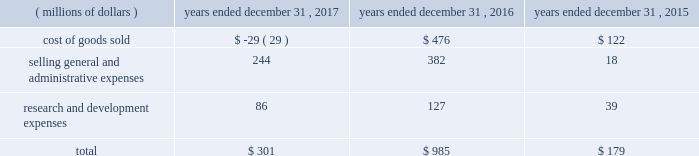Between the actual return on plan assets compared to the expected return on plan assets ( u.s .
Pension plans had an actual rate of return of 7.8 percent compared to an expected rate of return of 6.9 percent ) .
2022 2015 net mark-to-market loss of $ 179 million - primarily due to the difference between the actual return on plan assets compared to the expected return on plan assets ( u.s .
Pension plans had an actual rate of return of ( 2.0 ) percent compared to an expected rate of return of 7.4 percent ) which was partially offset by higher discount rates at the end of 2015 compared to 2014 .
The net mark-to-market losses were in the following results of operations line items: .
Effective january 1 , 2018 , we adopted new accounting guidance issued by the fasb related to the presentation of net periodic pension and opeb costs .
This guidance requires that an employer disaggregate the service cost component from the other components of net benefit cost .
Service cost is required to be reported in the same line item or items as other compensation costs arising from services rendered by the pertinent employees during the period .
The other components of net benefit cost are required to be reported outside the subtotal for income from operations .
As a result , components of pension and opeb costs , other than service costs , will be reclassified from operating costs to other income/expense .
This change will be applied retrospectively to prior years .
In the fourth quarter of 2017 , the company reviewed and made changes to the mortality assumptions primarily for our u.s .
Pension plans which resulted in an overall increase in the life expectancy of plan participants .
As of december 31 , 2017 these changes resulted in an increase in our liability for postemployment benefits of approximately $ 290 million .
In the fourth quarter of 2016 , the company adopted new mortality improvement scales released by the soa for our u.s .
Pension and opeb plans .
As of december 31 , 2016 , this resulted in an increase in our liability for postemployment benefits of approximately $ 200 million .
In the first quarter of 2017 , we announced the closure of our gosselies , belgium facility .
This announcement impacted certain employees that participated in a defined benefit pension plan and resulted in a curtailment and the recognition of termination benefits .
In march 2017 , we recognized a net loss of $ 20 million for the curtailment and termination benefits .
In addition , we announced the decision to phase out production at our aurora , illinois , facility , which resulted in termination benefits of $ 9 million for certain hourly employees that participate in our u.s .
Hourly defined benefit pension plan .
Beginning in 2016 , we elected to utilize a full yield curve approach in the estimation of service and interest costs by applying the specific spot rates along the yield curve used in the determination of the benefit obligation to the relevant projected cash flows .
Service and interest costs in 2017 and 2016 were lower by $ 140 million and $ 180 million , respectively , under the new method than they would have been under the previous method .
This change had no impact on our year-end defined benefit pension and opeb obligations or our annual net periodic benefit cost as the lower service and interest costs were entirely offset in the actuarial loss ( gain ) reported for the respective year .
We expect our total defined benefit pension and opeb expense ( excluding the impact of mark-to-market gains and losses ) to decrease approximately $ 80 million in 2018 .
This decrease is primarily due to a higher expected return on plan assets as a result of a higher asset base in 2018 .
In general , our strategy for both the u.s .
And the non-u.s .
Pensions includes ongoing alignment of our investments to our liabilities , while reducing risk in our portfolio .
For our u.s .
Pension plans , our year-end 2017 asset allocation was 34 a0percent equities , 62 a0percent fixed income and 4 percent other .
Our current u.s .
Pension target asset allocation is 30 percent equities and 70 percent fixed income .
The target allocation is revisited periodically to ensure it reflects our overall objectives .
The u.s .
Plans are rebalanced to plus or minus 5 percentage points of the target asset allocation ranges on a monthly basis .
The year-end 2017 asset allocation for our non-u.s .
Pension plans was 40 a0percent equities , 53 a0percent fixed income , 4 a0percent real estate and 3 percent other .
The 2017 weighted-average target allocations for our non-u.s .
Pension plans was 38 a0percent equities , 54 a0percent fixed income , 5 a0percent real estate and 3 a0percent other .
The target allocations for each plan vary based upon local statutory requirements , demographics of the plan participants and funded status .
The frequency of rebalancing for the non-u.s .
Plans varies depending on the plan .
Contributions to our pension and opeb plans were $ 1.6 billion and $ 329 million in 2017 and 2016 , respectively .
The 2017 contributions include a $ 1.0 billion discretionary contribution made to our u.s .
Pension plans in december 2017 .
We expect to make approximately $ 365 million of contributions to our pension and opeb plans in 2018 .
We believe we have adequate resources to fund both pension and opeb plans .
48 | 2017 form 10-k .
What were mandatory contributions to our pension and opeb plans in billions in 2017? 
Rationale: mandatory = total minus discretionary
Computations: (1.6 - 1)
Answer: 0.6. Between the actual return on plan assets compared to the expected return on plan assets ( u.s .
Pension plans had an actual rate of return of 7.8 percent compared to an expected rate of return of 6.9 percent ) .
2022 2015 net mark-to-market loss of $ 179 million - primarily due to the difference between the actual return on plan assets compared to the expected return on plan assets ( u.s .
Pension plans had an actual rate of return of ( 2.0 ) percent compared to an expected rate of return of 7.4 percent ) which was partially offset by higher discount rates at the end of 2015 compared to 2014 .
The net mark-to-market losses were in the following results of operations line items: .
Effective january 1 , 2018 , we adopted new accounting guidance issued by the fasb related to the presentation of net periodic pension and opeb costs .
This guidance requires that an employer disaggregate the service cost component from the other components of net benefit cost .
Service cost is required to be reported in the same line item or items as other compensation costs arising from services rendered by the pertinent employees during the period .
The other components of net benefit cost are required to be reported outside the subtotal for income from operations .
As a result , components of pension and opeb costs , other than service costs , will be reclassified from operating costs to other income/expense .
This change will be applied retrospectively to prior years .
In the fourth quarter of 2017 , the company reviewed and made changes to the mortality assumptions primarily for our u.s .
Pension plans which resulted in an overall increase in the life expectancy of plan participants .
As of december 31 , 2017 these changes resulted in an increase in our liability for postemployment benefits of approximately $ 290 million .
In the fourth quarter of 2016 , the company adopted new mortality improvement scales released by the soa for our u.s .
Pension and opeb plans .
As of december 31 , 2016 , this resulted in an increase in our liability for postemployment benefits of approximately $ 200 million .
In the first quarter of 2017 , we announced the closure of our gosselies , belgium facility .
This announcement impacted certain employees that participated in a defined benefit pension plan and resulted in a curtailment and the recognition of termination benefits .
In march 2017 , we recognized a net loss of $ 20 million for the curtailment and termination benefits .
In addition , we announced the decision to phase out production at our aurora , illinois , facility , which resulted in termination benefits of $ 9 million for certain hourly employees that participate in our u.s .
Hourly defined benefit pension plan .
Beginning in 2016 , we elected to utilize a full yield curve approach in the estimation of service and interest costs by applying the specific spot rates along the yield curve used in the determination of the benefit obligation to the relevant projected cash flows .
Service and interest costs in 2017 and 2016 were lower by $ 140 million and $ 180 million , respectively , under the new method than they would have been under the previous method .
This change had no impact on our year-end defined benefit pension and opeb obligations or our annual net periodic benefit cost as the lower service and interest costs were entirely offset in the actuarial loss ( gain ) reported for the respective year .
We expect our total defined benefit pension and opeb expense ( excluding the impact of mark-to-market gains and losses ) to decrease approximately $ 80 million in 2018 .
This decrease is primarily due to a higher expected return on plan assets as a result of a higher asset base in 2018 .
In general , our strategy for both the u.s .
And the non-u.s .
Pensions includes ongoing alignment of our investments to our liabilities , while reducing risk in our portfolio .
For our u.s .
Pension plans , our year-end 2017 asset allocation was 34 a0percent equities , 62 a0percent fixed income and 4 percent other .
Our current u.s .
Pension target asset allocation is 30 percent equities and 70 percent fixed income .
The target allocation is revisited periodically to ensure it reflects our overall objectives .
The u.s .
Plans are rebalanced to plus or minus 5 percentage points of the target asset allocation ranges on a monthly basis .
The year-end 2017 asset allocation for our non-u.s .
Pension plans was 40 a0percent equities , 53 a0percent fixed income , 4 a0percent real estate and 3 percent other .
The 2017 weighted-average target allocations for our non-u.s .
Pension plans was 38 a0percent equities , 54 a0percent fixed income , 5 a0percent real estate and 3 a0percent other .
The target allocations for each plan vary based upon local statutory requirements , demographics of the plan participants and funded status .
The frequency of rebalancing for the non-u.s .
Plans varies depending on the plan .
Contributions to our pension and opeb plans were $ 1.6 billion and $ 329 million in 2017 and 2016 , respectively .
The 2017 contributions include a $ 1.0 billion discretionary contribution made to our u.s .
Pension plans in december 2017 .
We expect to make approximately $ 365 million of contributions to our pension and opeb plans in 2018 .
We believe we have adequate resources to fund both pension and opeb plans .
48 | 2017 form 10-k .
What is the expected growth rate in pension and opb contributions from 2017 to 2018? 
Computations: ((365 - (1000 * 1.6)) / (1000 * 1.6))
Answer: -0.77187. Between the actual return on plan assets compared to the expected return on plan assets ( u.s .
Pension plans had an actual rate of return of 7.8 percent compared to an expected rate of return of 6.9 percent ) .
2022 2015 net mark-to-market loss of $ 179 million - primarily due to the difference between the actual return on plan assets compared to the expected return on plan assets ( u.s .
Pension plans had an actual rate of return of ( 2.0 ) percent compared to an expected rate of return of 7.4 percent ) which was partially offset by higher discount rates at the end of 2015 compared to 2014 .
The net mark-to-market losses were in the following results of operations line items: .
Effective january 1 , 2018 , we adopted new accounting guidance issued by the fasb related to the presentation of net periodic pension and opeb costs .
This guidance requires that an employer disaggregate the service cost component from the other components of net benefit cost .
Service cost is required to be reported in the same line item or items as other compensation costs arising from services rendered by the pertinent employees during the period .
The other components of net benefit cost are required to be reported outside the subtotal for income from operations .
As a result , components of pension and opeb costs , other than service costs , will be reclassified from operating costs to other income/expense .
This change will be applied retrospectively to prior years .
In the fourth quarter of 2017 , the company reviewed and made changes to the mortality assumptions primarily for our u.s .
Pension plans which resulted in an overall increase in the life expectancy of plan participants .
As of december 31 , 2017 these changes resulted in an increase in our liability for postemployment benefits of approximately $ 290 million .
In the fourth quarter of 2016 , the company adopted new mortality improvement scales released by the soa for our u.s .
Pension and opeb plans .
As of december 31 , 2016 , this resulted in an increase in our liability for postemployment benefits of approximately $ 200 million .
In the first quarter of 2017 , we announced the closure of our gosselies , belgium facility .
This announcement impacted certain employees that participated in a defined benefit pension plan and resulted in a curtailment and the recognition of termination benefits .
In march 2017 , we recognized a net loss of $ 20 million for the curtailment and termination benefits .
In addition , we announced the decision to phase out production at our aurora , illinois , facility , which resulted in termination benefits of $ 9 million for certain hourly employees that participate in our u.s .
Hourly defined benefit pension plan .
Beginning in 2016 , we elected to utilize a full yield curve approach in the estimation of service and interest costs by applying the specific spot rates along the yield curve used in the determination of the benefit obligation to the relevant projected cash flows .
Service and interest costs in 2017 and 2016 were lower by $ 140 million and $ 180 million , respectively , under the new method than they would have been under the previous method .
This change had no impact on our year-end defined benefit pension and opeb obligations or our annual net periodic benefit cost as the lower service and interest costs were entirely offset in the actuarial loss ( gain ) reported for the respective year .
We expect our total defined benefit pension and opeb expense ( excluding the impact of mark-to-market gains and losses ) to decrease approximately $ 80 million in 2018 .
This decrease is primarily due to a higher expected return on plan assets as a result of a higher asset base in 2018 .
In general , our strategy for both the u.s .
And the non-u.s .
Pensions includes ongoing alignment of our investments to our liabilities , while reducing risk in our portfolio .
For our u.s .
Pension plans , our year-end 2017 asset allocation was 34 a0percent equities , 62 a0percent fixed income and 4 percent other .
Our current u.s .
Pension target asset allocation is 30 percent equities and 70 percent fixed income .
The target allocation is revisited periodically to ensure it reflects our overall objectives .
The u.s .
Plans are rebalanced to plus or minus 5 percentage points of the target asset allocation ranges on a monthly basis .
The year-end 2017 asset allocation for our non-u.s .
Pension plans was 40 a0percent equities , 53 a0percent fixed income , 4 a0percent real estate and 3 percent other .
The 2017 weighted-average target allocations for our non-u.s .
Pension plans was 38 a0percent equities , 54 a0percent fixed income , 5 a0percent real estate and 3 a0percent other .
The target allocations for each plan vary based upon local statutory requirements , demographics of the plan participants and funded status .
The frequency of rebalancing for the non-u.s .
Plans varies depending on the plan .
Contributions to our pension and opeb plans were $ 1.6 billion and $ 329 million in 2017 and 2016 , respectively .
The 2017 contributions include a $ 1.0 billion discretionary contribution made to our u.s .
Pension plans in december 2017 .
We expect to make approximately $ 365 million of contributions to our pension and opeb plans in 2018 .
We believe we have adequate resources to fund both pension and opeb plans .
48 | 2017 form 10-k .
What portion of the net mark-to-market loss were driven by cost of good sold in 2015? 
Computations: (122 / 179)
Answer: 0.68156. 